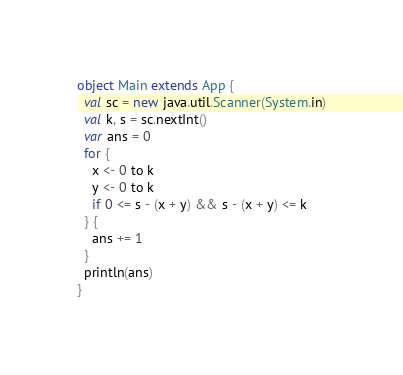Convert code to text. <code><loc_0><loc_0><loc_500><loc_500><_Scala_>object Main extends App {
  val sc = new java.util.Scanner(System.in)
  val k, s = sc.nextInt()
  var ans = 0
  for {
    x <- 0 to k
    y <- 0 to k
    if 0 <= s - (x + y) && s - (x + y) <= k
  } {
    ans += 1
  }
  println(ans)
}
</code> 